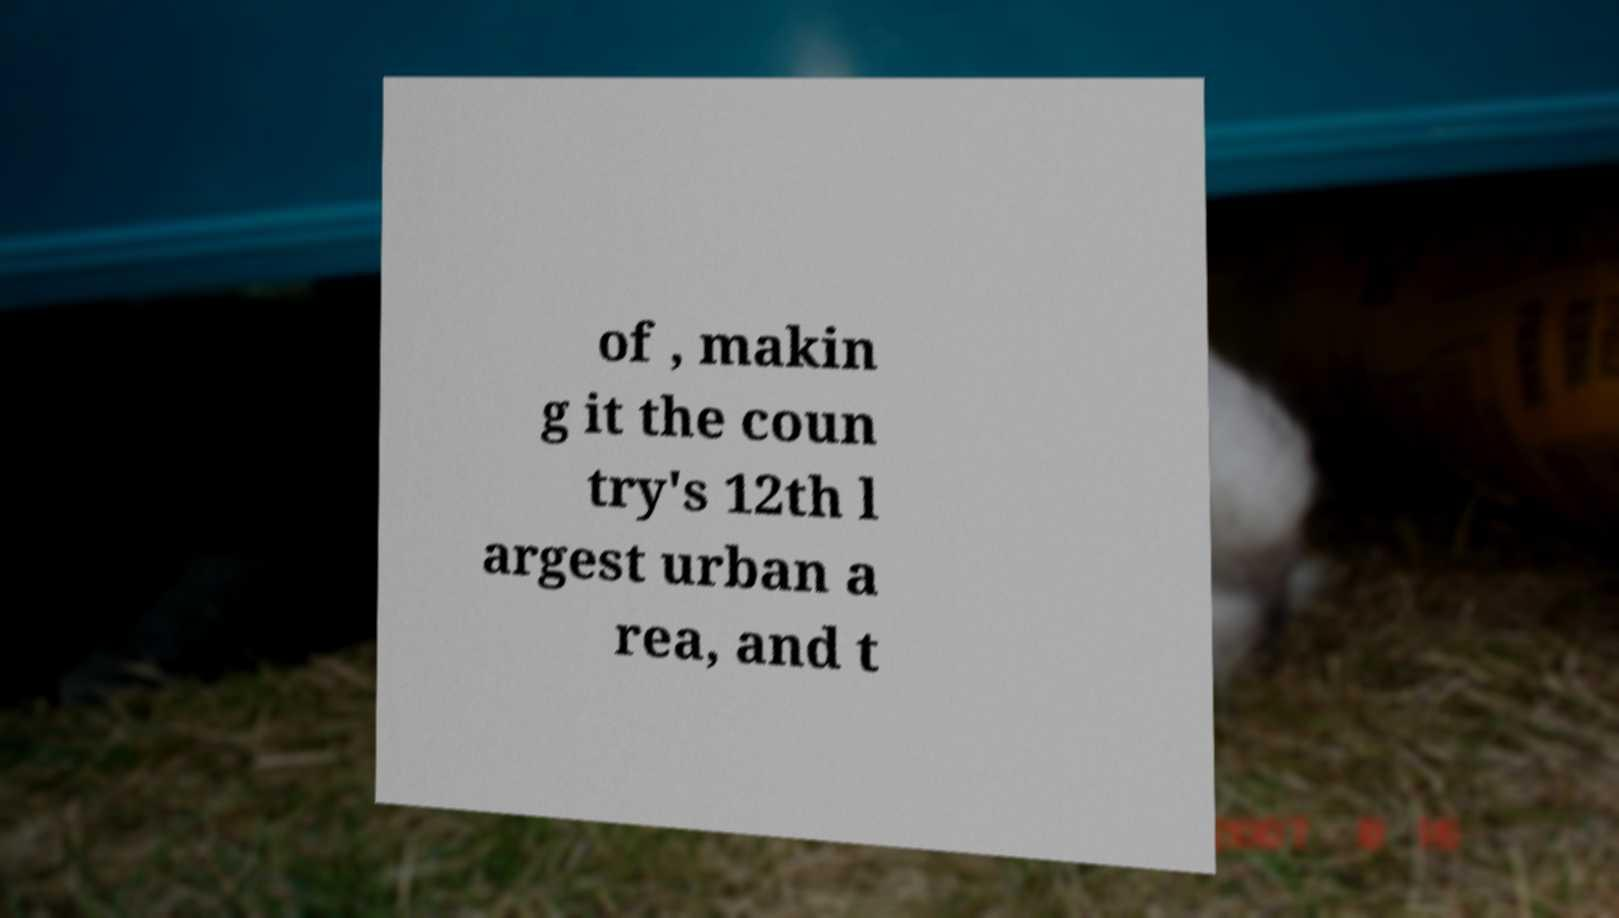For documentation purposes, I need the text within this image transcribed. Could you provide that? of , makin g it the coun try's 12th l argest urban a rea, and t 